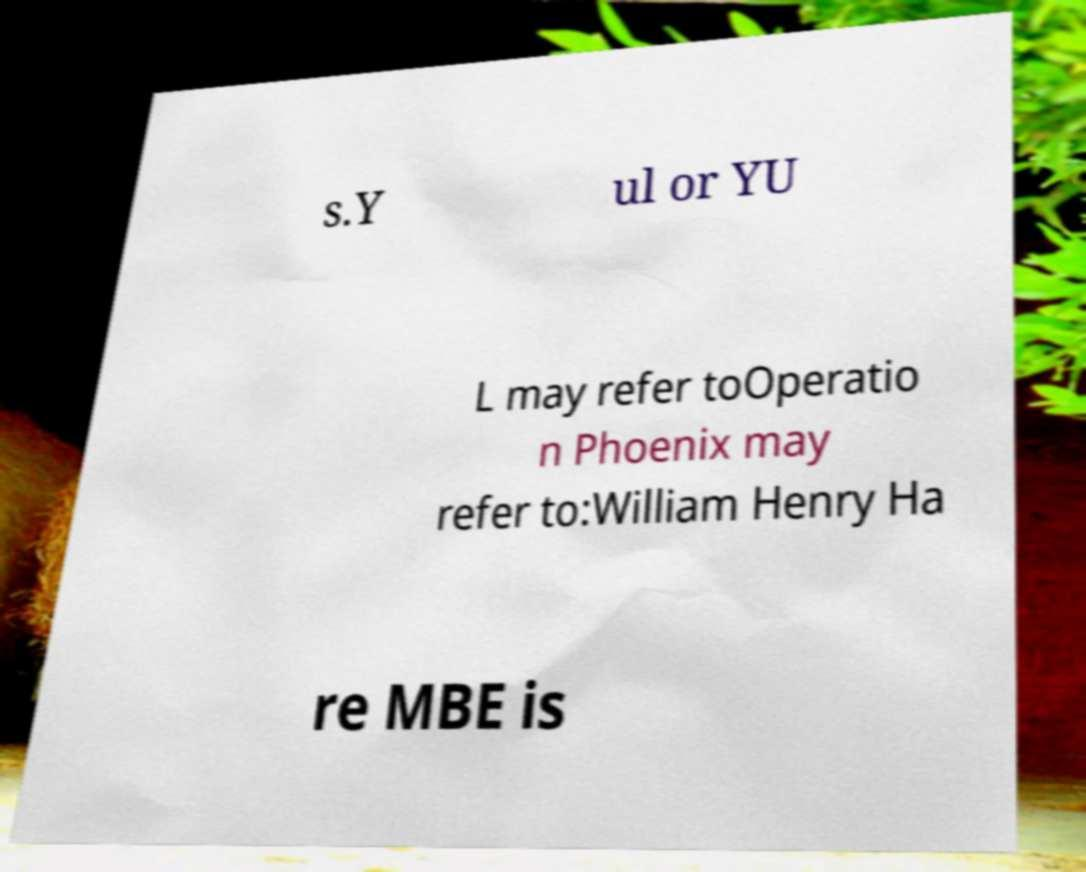Can you accurately transcribe the text from the provided image for me? s.Y ul or YU L may refer toOperatio n Phoenix may refer to:William Henry Ha re MBE is 